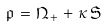<formula> <loc_0><loc_0><loc_500><loc_500>\mathfrak { p } \, = \, \mathfrak { N } _ { + } \, + \, \kappa \, \mathfrak { S }</formula> 